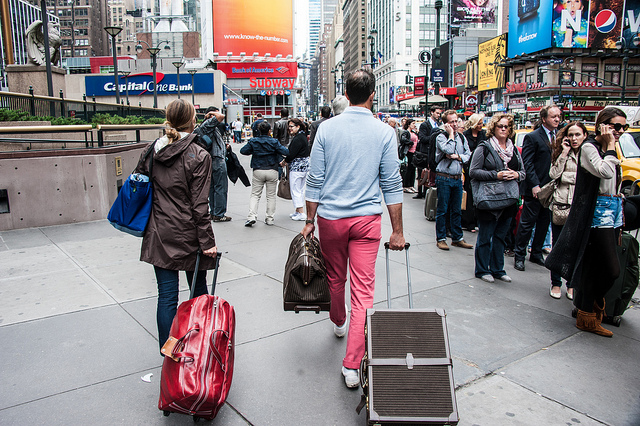Identify the text contained in this image. S Capital One Bank Subway www.kkow-the-number.com Subway M NOW i 